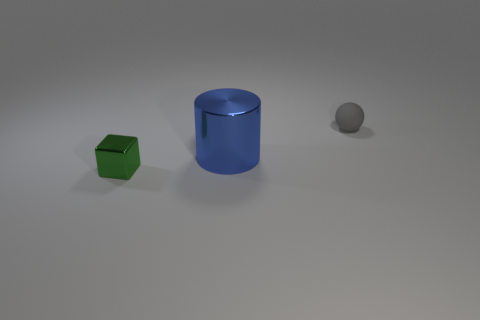Add 1 large yellow matte balls. How many objects exist? 4 Subtract all cubes. How many objects are left? 2 Add 3 tiny green cubes. How many tiny green cubes are left? 4 Add 1 tiny red rubber cylinders. How many tiny red rubber cylinders exist? 1 Subtract 0 red balls. How many objects are left? 3 Subtract all big objects. Subtract all metal objects. How many objects are left? 0 